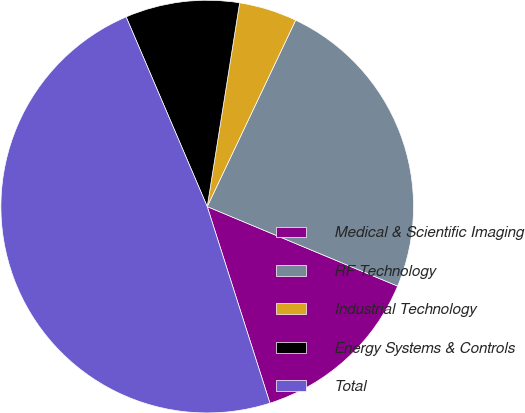Convert chart to OTSL. <chart><loc_0><loc_0><loc_500><loc_500><pie_chart><fcel>Medical & Scientific Imaging<fcel>RF Technology<fcel>Industrial Technology<fcel>Energy Systems & Controls<fcel>Total<nl><fcel>13.79%<fcel>24.25%<fcel>4.54%<fcel>8.94%<fcel>48.49%<nl></chart> 